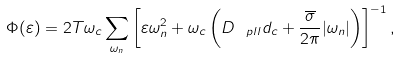Convert formula to latex. <formula><loc_0><loc_0><loc_500><loc_500>\Phi ( \varepsilon ) = 2 T \omega _ { c } \sum _ { \omega _ { n } } \left [ \varepsilon \omega _ { n } ^ { 2 } + \omega _ { c } \left ( D _ { _ { \ } p l l } d _ { c } + \frac { \overline { \sigma } } { 2 \pi } | \omega _ { n } | \right ) \right ] ^ { - 1 } ,</formula> 